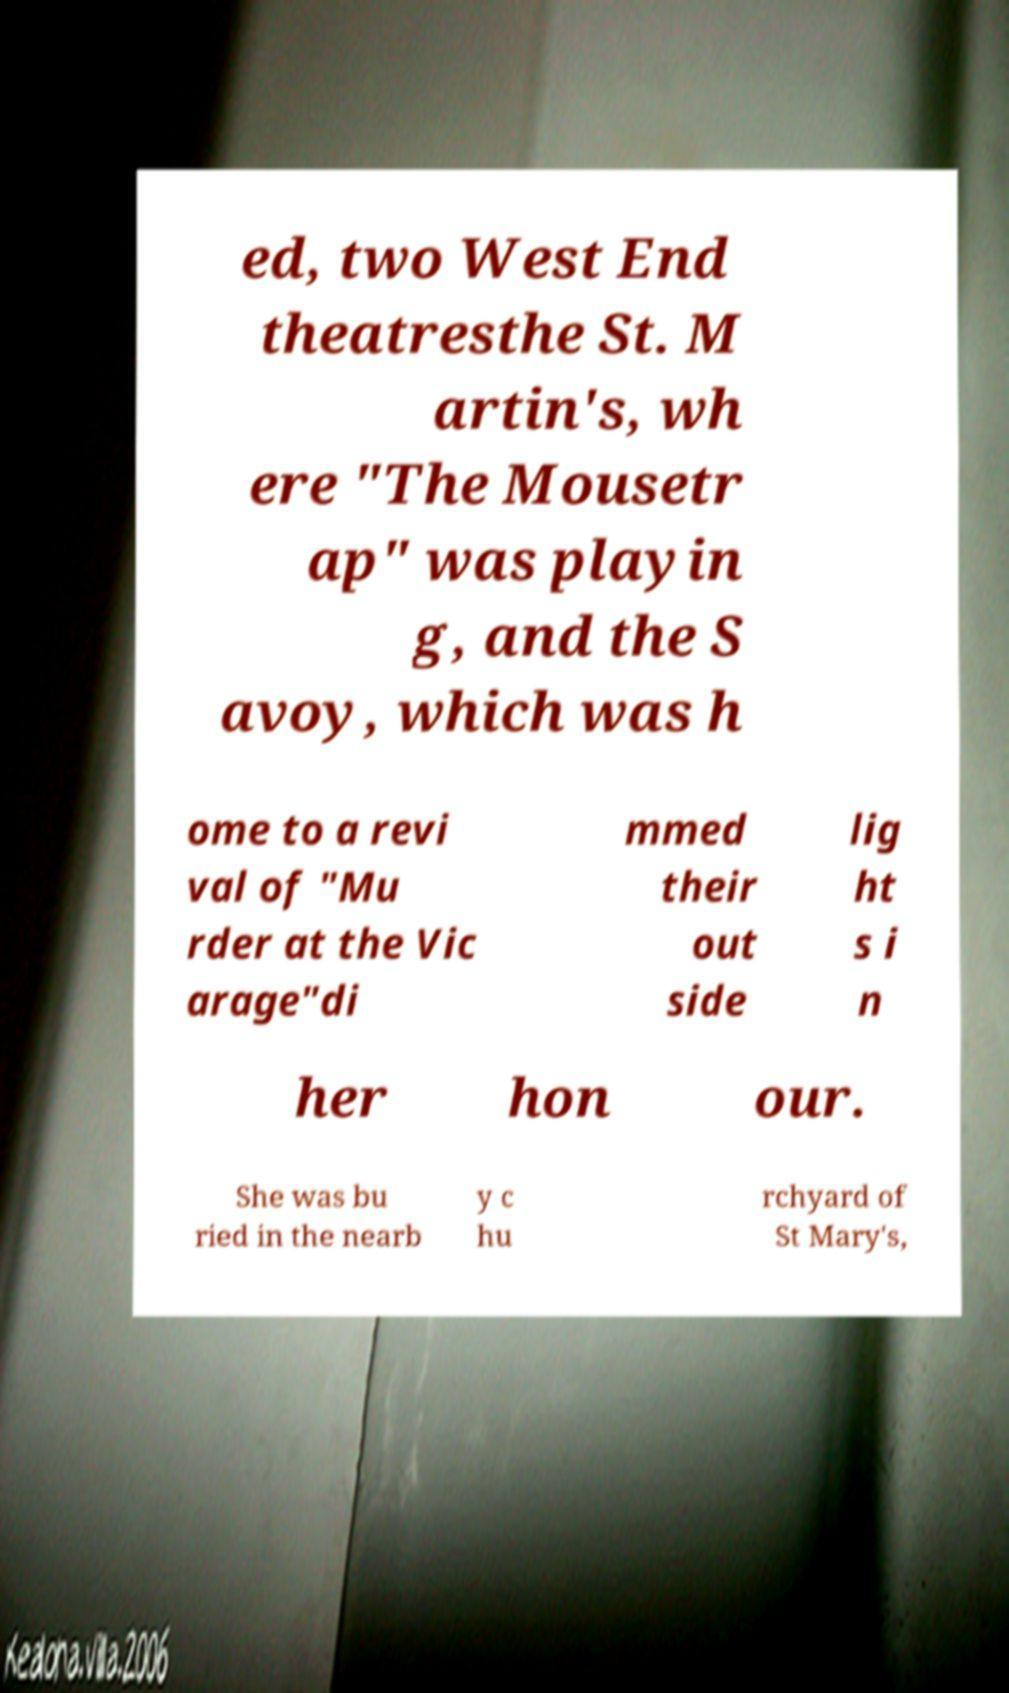What messages or text are displayed in this image? I need them in a readable, typed format. ed, two West End theatresthe St. M artin's, wh ere "The Mousetr ap" was playin g, and the S avoy, which was h ome to a revi val of "Mu rder at the Vic arage"di mmed their out side lig ht s i n her hon our. She was bu ried in the nearb y c hu rchyard of St Mary's, 